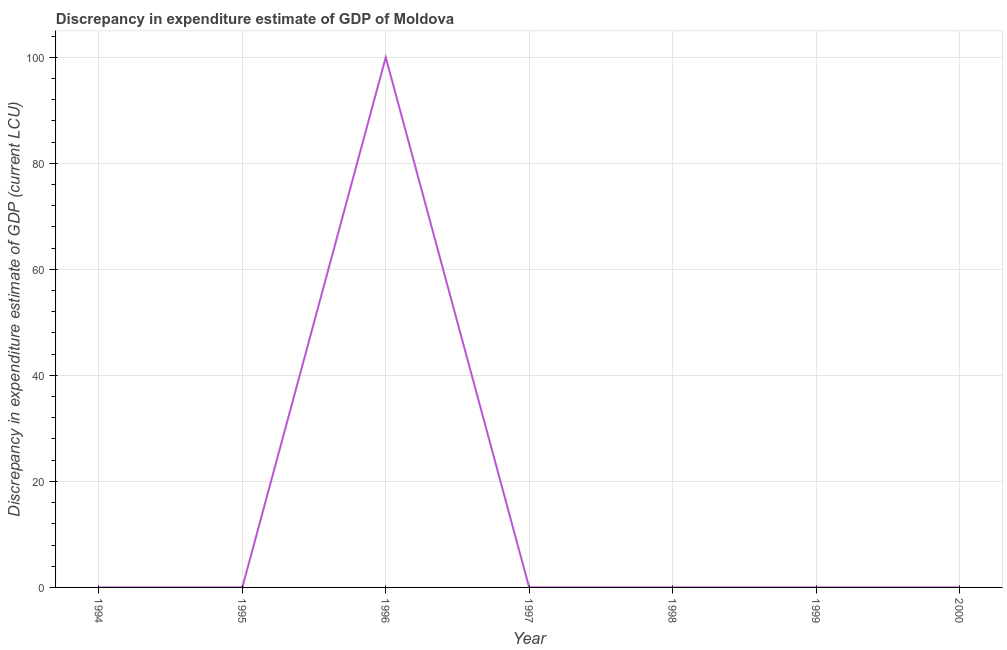What is the discrepancy in expenditure estimate of gdp in 1996?
Ensure brevity in your answer.  100. Across all years, what is the maximum discrepancy in expenditure estimate of gdp?
Keep it short and to the point. 100. Across all years, what is the minimum discrepancy in expenditure estimate of gdp?
Offer a terse response. 0. In which year was the discrepancy in expenditure estimate of gdp maximum?
Give a very brief answer. 1996. What is the sum of the discrepancy in expenditure estimate of gdp?
Give a very brief answer. 100. What is the difference between the discrepancy in expenditure estimate of gdp in 1994 and 1998?
Your response must be concise. -3e-7. What is the average discrepancy in expenditure estimate of gdp per year?
Your answer should be compact. 14.29. What is the median discrepancy in expenditure estimate of gdp?
Ensure brevity in your answer.  1e-6. In how many years, is the discrepancy in expenditure estimate of gdp greater than 96 LCU?
Give a very brief answer. 1. What is the ratio of the discrepancy in expenditure estimate of gdp in 1994 to that in 1999?
Ensure brevity in your answer.  0.47. Is the discrepancy in expenditure estimate of gdp in 1994 less than that in 1998?
Give a very brief answer. Yes. What is the difference between the highest and the second highest discrepancy in expenditure estimate of gdp?
Keep it short and to the point. 100. Is the sum of the discrepancy in expenditure estimate of gdp in 1995 and 2000 greater than the maximum discrepancy in expenditure estimate of gdp across all years?
Give a very brief answer. No. What is the difference between the highest and the lowest discrepancy in expenditure estimate of gdp?
Offer a very short reply. 100. In how many years, is the discrepancy in expenditure estimate of gdp greater than the average discrepancy in expenditure estimate of gdp taken over all years?
Provide a succinct answer. 1. What is the difference between two consecutive major ticks on the Y-axis?
Keep it short and to the point. 20. Are the values on the major ticks of Y-axis written in scientific E-notation?
Make the answer very short. No. Does the graph contain grids?
Offer a very short reply. Yes. What is the title of the graph?
Give a very brief answer. Discrepancy in expenditure estimate of GDP of Moldova. What is the label or title of the X-axis?
Your response must be concise. Year. What is the label or title of the Y-axis?
Your response must be concise. Discrepancy in expenditure estimate of GDP (current LCU). What is the Discrepancy in expenditure estimate of GDP (current LCU) of 1994?
Keep it short and to the point. 7e-7. What is the Discrepancy in expenditure estimate of GDP (current LCU) of 1995?
Give a very brief answer. 5e-7. What is the Discrepancy in expenditure estimate of GDP (current LCU) of 1996?
Provide a short and direct response. 100. What is the Discrepancy in expenditure estimate of GDP (current LCU) in 1997?
Your answer should be very brief. 0. What is the Discrepancy in expenditure estimate of GDP (current LCU) of 1998?
Provide a succinct answer. 1e-6. What is the Discrepancy in expenditure estimate of GDP (current LCU) in 1999?
Your answer should be compact. 1.5e-6. What is the Discrepancy in expenditure estimate of GDP (current LCU) in 2000?
Provide a succinct answer. 1.5e-6. What is the difference between the Discrepancy in expenditure estimate of GDP (current LCU) in 1994 and 1995?
Keep it short and to the point. 0. What is the difference between the Discrepancy in expenditure estimate of GDP (current LCU) in 1994 and 1996?
Offer a very short reply. -100. What is the difference between the Discrepancy in expenditure estimate of GDP (current LCU) in 1995 and 1996?
Provide a short and direct response. -100. What is the difference between the Discrepancy in expenditure estimate of GDP (current LCU) in 1995 and 2000?
Provide a succinct answer. -0. What is the difference between the Discrepancy in expenditure estimate of GDP (current LCU) in 1996 and 1999?
Your answer should be compact. 100. What is the difference between the Discrepancy in expenditure estimate of GDP (current LCU) in 1996 and 2000?
Give a very brief answer. 100. What is the difference between the Discrepancy in expenditure estimate of GDP (current LCU) in 1999 and 2000?
Offer a terse response. 0. What is the ratio of the Discrepancy in expenditure estimate of GDP (current LCU) in 1994 to that in 1995?
Make the answer very short. 1.4. What is the ratio of the Discrepancy in expenditure estimate of GDP (current LCU) in 1994 to that in 1996?
Ensure brevity in your answer.  0. What is the ratio of the Discrepancy in expenditure estimate of GDP (current LCU) in 1994 to that in 1998?
Give a very brief answer. 0.7. What is the ratio of the Discrepancy in expenditure estimate of GDP (current LCU) in 1994 to that in 1999?
Make the answer very short. 0.47. What is the ratio of the Discrepancy in expenditure estimate of GDP (current LCU) in 1994 to that in 2000?
Provide a succinct answer. 0.47. What is the ratio of the Discrepancy in expenditure estimate of GDP (current LCU) in 1995 to that in 1999?
Ensure brevity in your answer.  0.33. What is the ratio of the Discrepancy in expenditure estimate of GDP (current LCU) in 1995 to that in 2000?
Your response must be concise. 0.33. What is the ratio of the Discrepancy in expenditure estimate of GDP (current LCU) in 1996 to that in 1998?
Your response must be concise. 1.00e+08. What is the ratio of the Discrepancy in expenditure estimate of GDP (current LCU) in 1996 to that in 1999?
Make the answer very short. 6.67e+07. What is the ratio of the Discrepancy in expenditure estimate of GDP (current LCU) in 1996 to that in 2000?
Ensure brevity in your answer.  6.67e+07. What is the ratio of the Discrepancy in expenditure estimate of GDP (current LCU) in 1998 to that in 1999?
Keep it short and to the point. 0.67. What is the ratio of the Discrepancy in expenditure estimate of GDP (current LCU) in 1998 to that in 2000?
Your response must be concise. 0.67. 